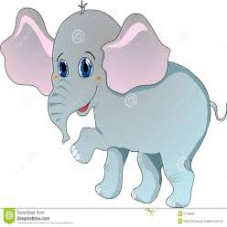How might the design of this cartoon elephant contribute to its appeal to children? The design of the cartoon elephant is carefully tailored to captivate children. Its large, expressive eyes and oversized features, such as the big ears, create a sense of innocence and friendliness that can be very appealing to a young audience. The soft, rounded contours of the elephant's body make it appear safe and cuddly. Moreover, the choice of gentle, pastel colors adds to this allure, making it visually appealing and engaging for children by evoking a sense of warmth and comfort. 